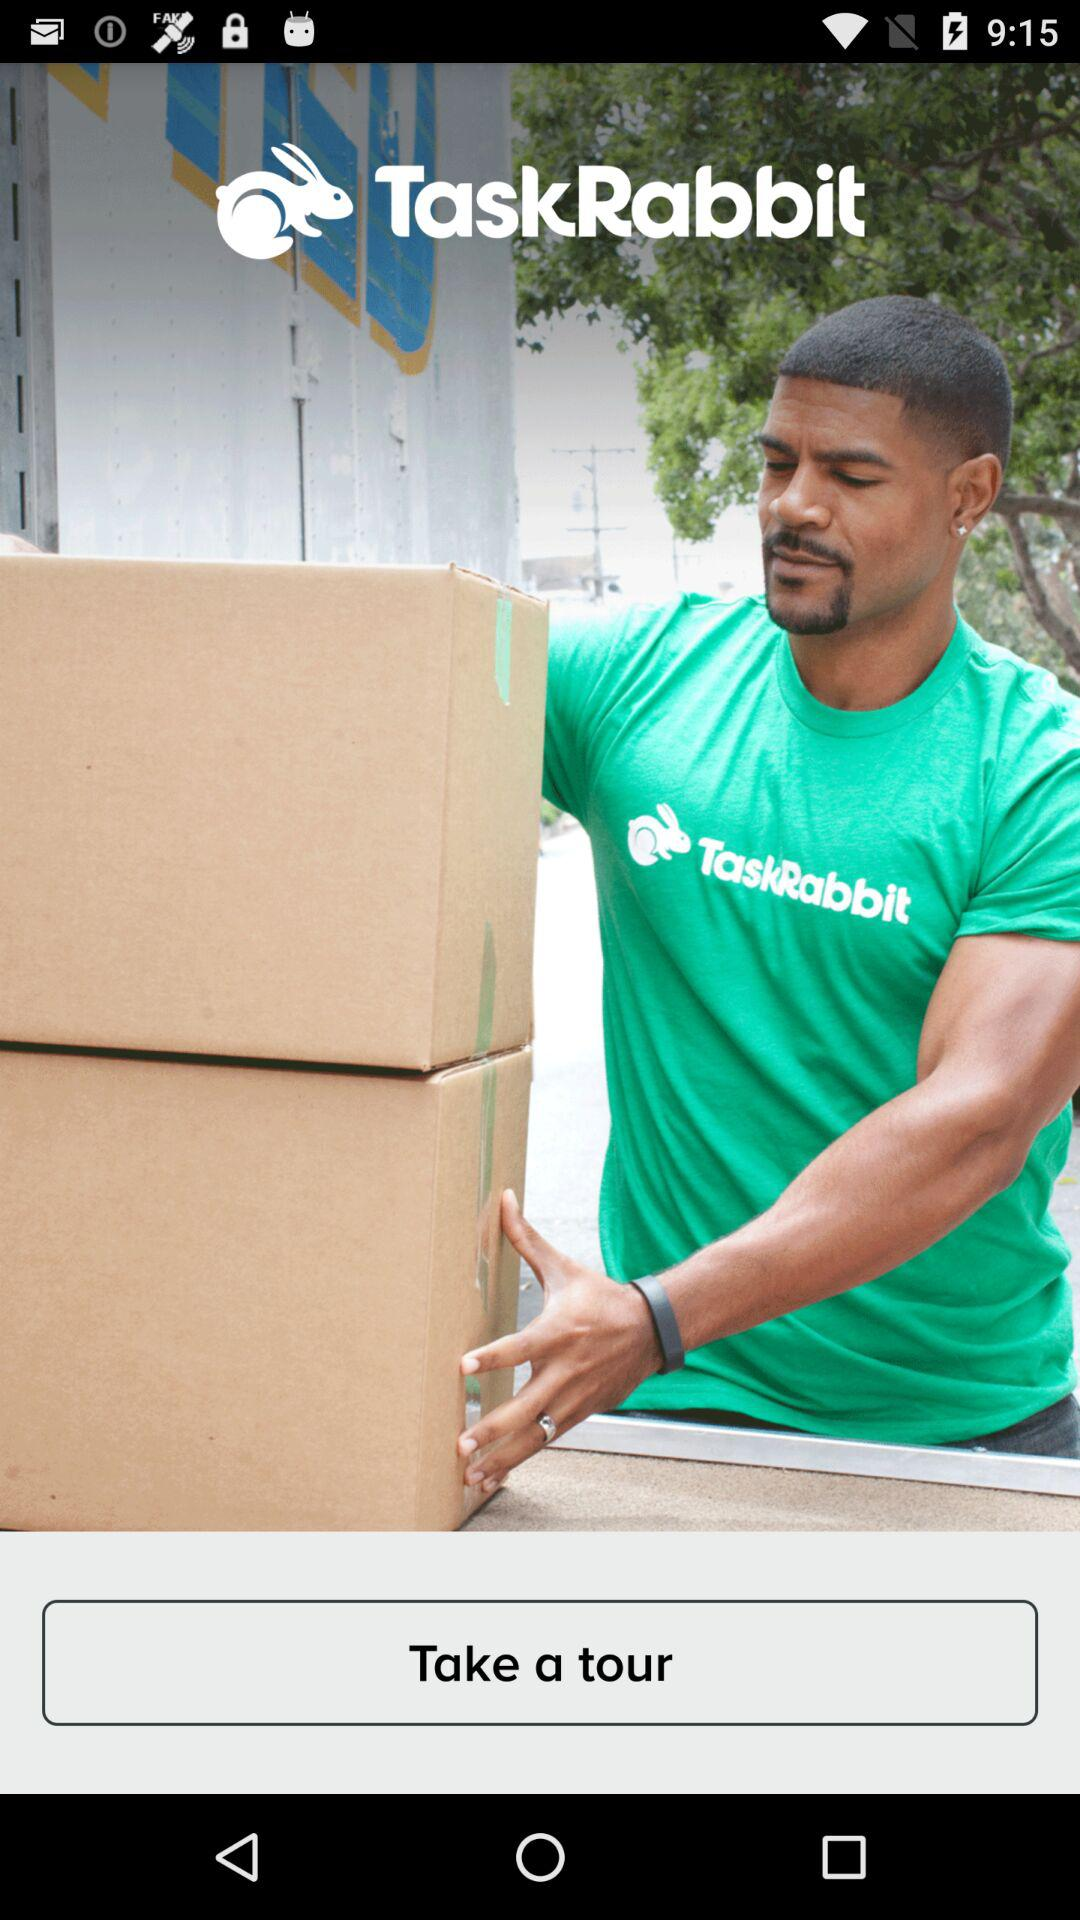What is the application name? The application name is "TaskRabbit". 